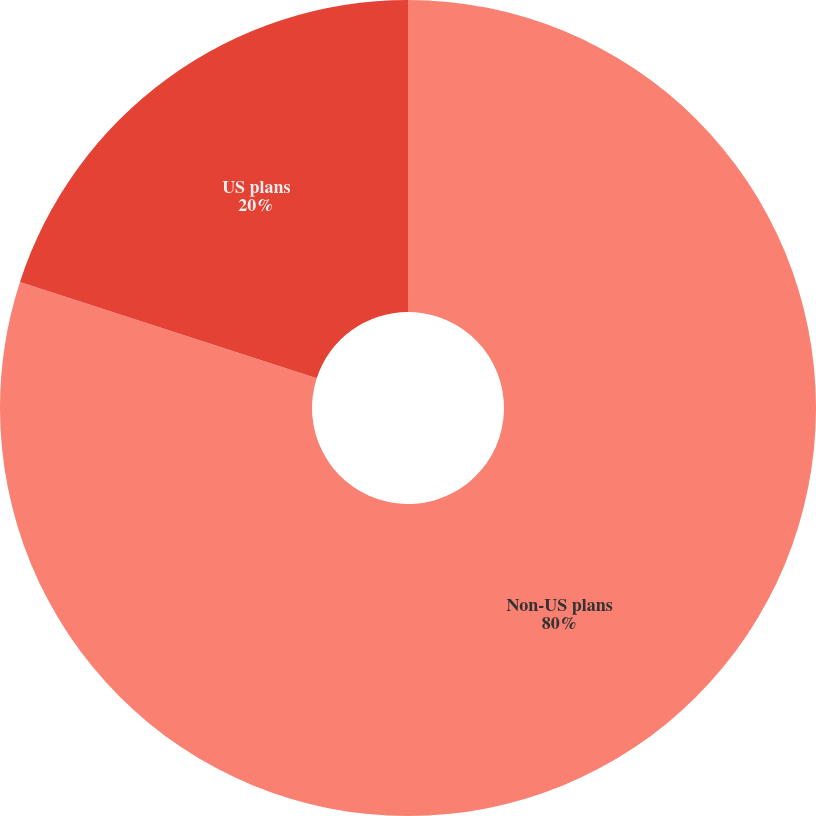Convert chart. <chart><loc_0><loc_0><loc_500><loc_500><pie_chart><fcel>Non-US plans<fcel>US plans<nl><fcel>80.0%<fcel>20.0%<nl></chart> 